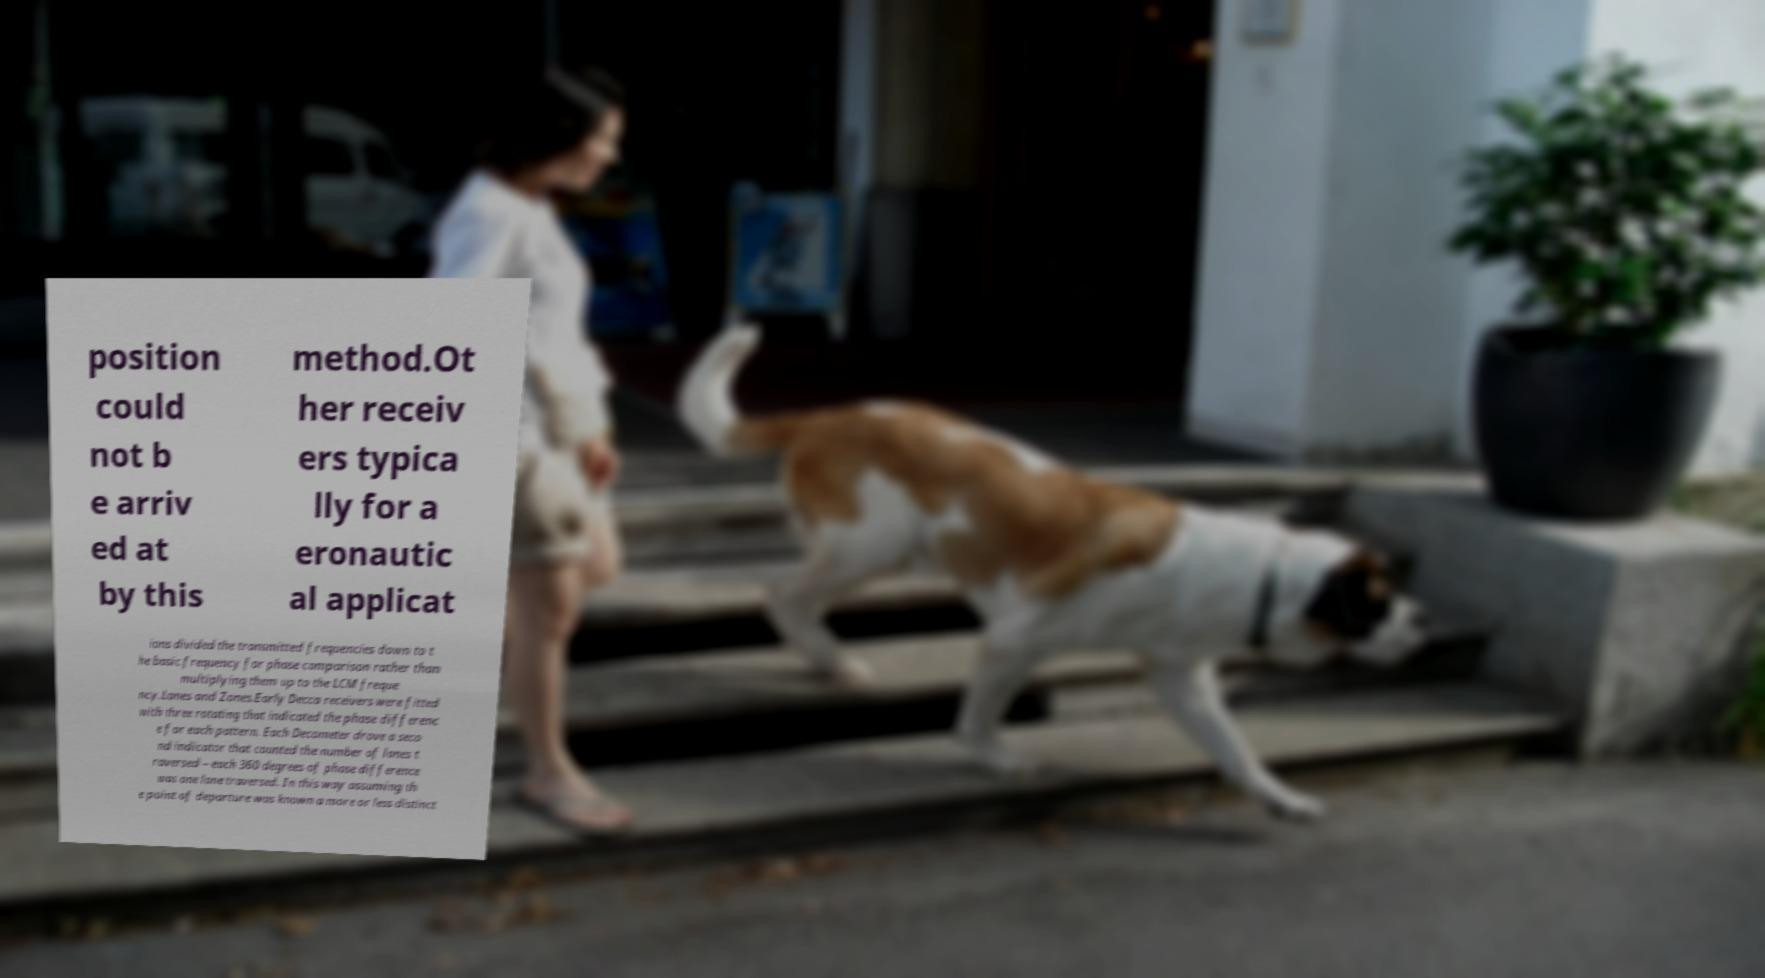I need the written content from this picture converted into text. Can you do that? position could not b e arriv ed at by this method.Ot her receiv ers typica lly for a eronautic al applicat ions divided the transmitted frequencies down to t he basic frequency for phase comparison rather than multiplying them up to the LCM freque ncy.Lanes and Zones.Early Decca receivers were fitted with three rotating that indicated the phase differenc e for each pattern. Each Decometer drove a seco nd indicator that counted the number of lanes t raversed – each 360 degrees of phase difference was one lane traversed. In this way assuming th e point of departure was known a more or less distinct 